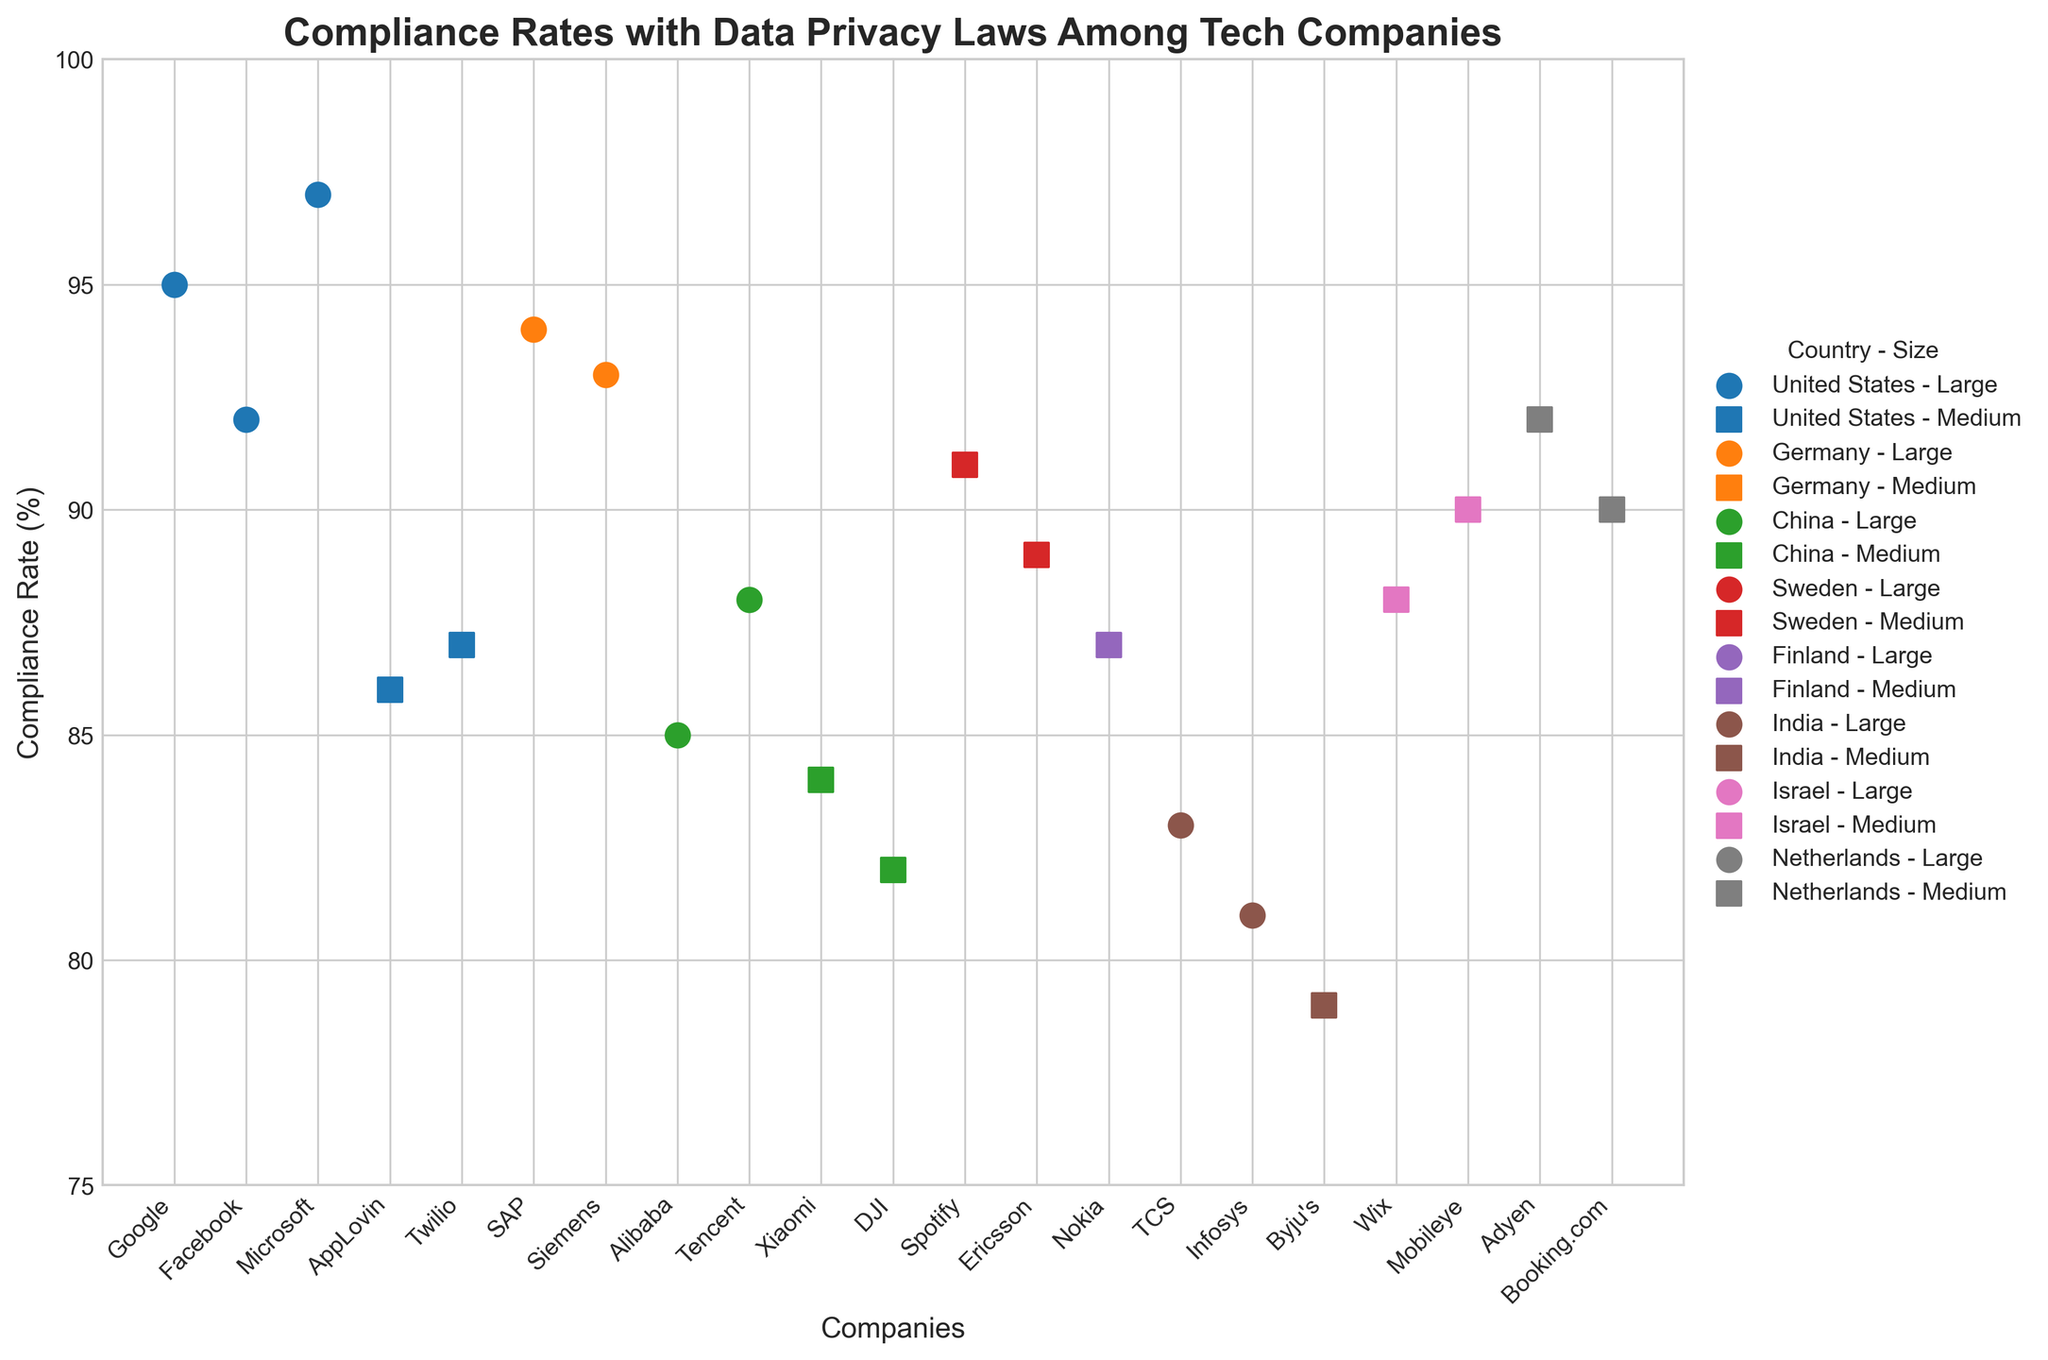What is the title of the plot? The title of the plot is located at the top of the figure. It is typically bolded and larger in font size to distinguish it from other text. The title gives a concise description of what the plot represents.
Answer: Compliance Rates with Data Privacy Laws Among Tech Companies What is the highest compliance rate among companies in China? Look for the data points marked with the color representing China (green). Identify the maximum value on the vertical axis (Compliance Rate) among these points.
Answer: 88 Which company in the United States has the highest compliance rate? Locate the data points marked with the color representing the United States (blue). Among these, find the point corresponding to the highest value on the vertical axis (Compliance Rate).
Answer: Microsoft Compare the compliance rates of large companies in Germany and China. Which country has a higher average compliance rate in this category? Calculate the average compliance rate of large companies in Germany and China. For Germany: (94 + 93) / 2 = 93.5. For China: 85.
Answer: Germany How many countries are represented in the plot? Differentiate by the unique colors in the plot, each representing a different country. Count these unique colors.
Answer: 8 What is the difference in compliance rates between the medium-sized company with the highest compliance rate and the one with the lowest? Identify the highest and lowest compliance rates in the medium-sized category by looking at the two shapes representing medium-sized companies (square markers). Subtract the lowest rate from the highest.
Answer: 92 - 79 = 13 Which medium-sized company in Israel has a higher compliance rate, Wix or Mobileye? Identify the data points marked with the color representing Israel (pink) and find the medium-sized marker (square) for Wix and Mobileye. Compare their positions on the vertical axis (Compliance Rate).
Answer: Mobileye What is the collective average compliance rate for all medium-sized companies in Europe (Germany, Sweden, Finland, Netherlands)? Identify the medium-sized companies in these countries and calculate their average compliance rate: (91+89+87+92+90)/5.
Answer: 89.8 Is there a clear visual trend in compliance rates based on company size within each country? Observe the plot for patterns in compliance rates differentiating between large (circles) and medium-sized (squares) companies within each country.
Answer: Generally, large companies have higher compliance rates Which large company in India has the lowest compliance rate? Locate the large companies in India by identifying data points marked with the color representing India (brown) and look for the marker shape representing large companies. Find the lowest value on the vertical axis (Compliance Rate).
Answer: Infosys 